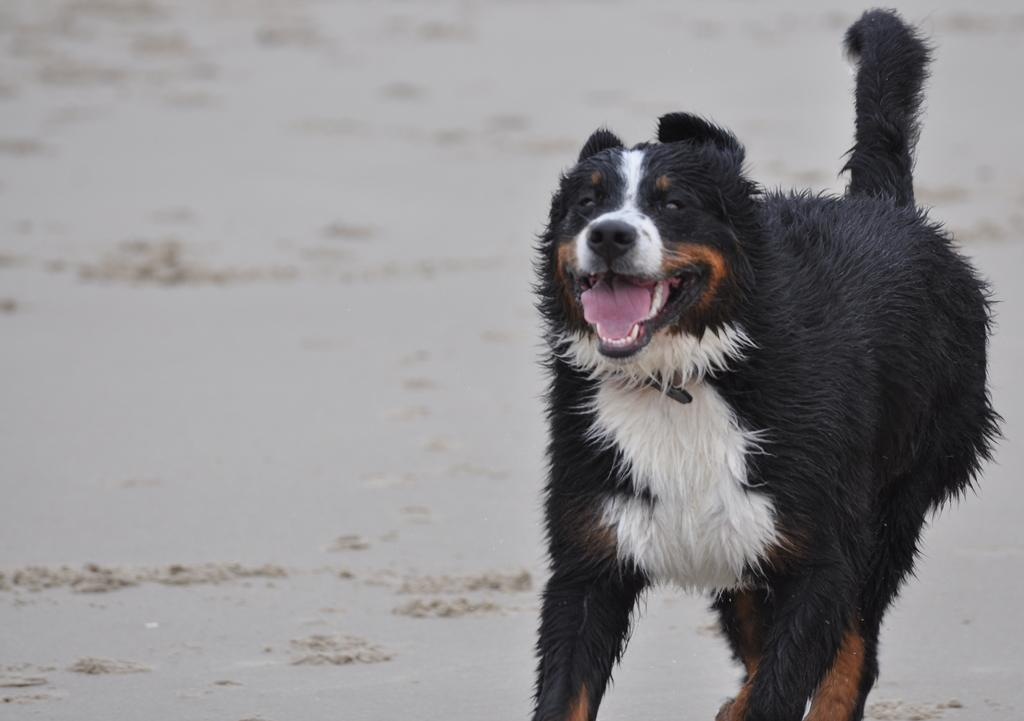What type of animal is in the image? There is a dog in the image. What is the dog's position in the image? The dog is standing on the ground. What advice does the dog's grandfather give to the dog in the image? There is no mention of a grandfather or any advice in the image; it simply shows a dog standing on the ground. 